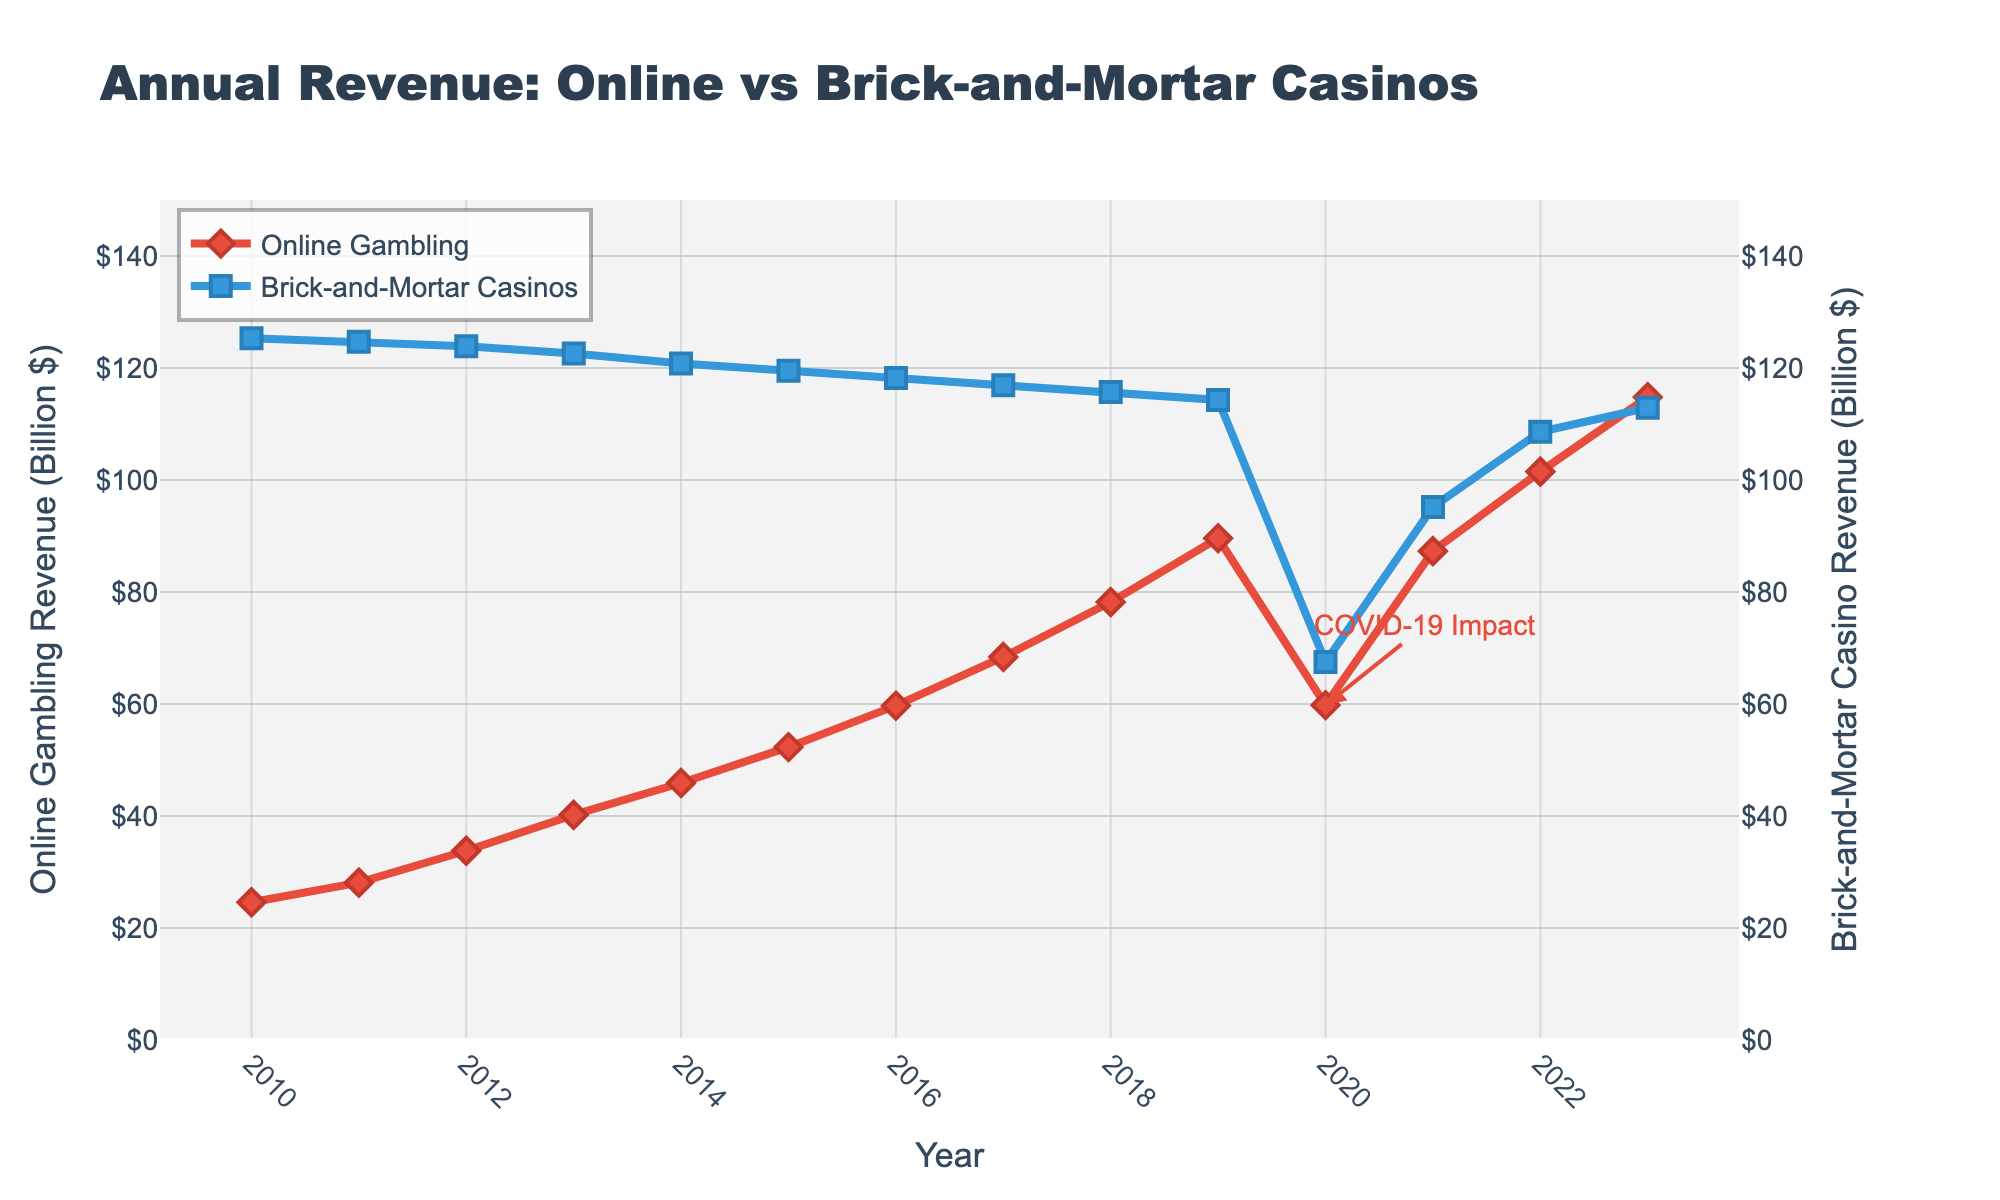What's the annual revenue of online gambling platforms in 2015? According to the figure, the data marker for 2015 representing the annual revenue of online gambling platforms is at 52.3 billion dollars.
Answer: 52.3 billion dollars How did the revenue of brick-and-mortar casinos change from 2010 to 2023? The revenue of brick-and-mortar casinos started at 125.3 billion dollars in 2010 and descended to 112.9 billion dollars in 2023. This indicates a gradual decline over the years.
Answer: Decreased from 125.3 to 112.9 billion dollars Which type of casino experienced a greater impact during the year 2020, and why? By observing the sharp decline in the graph for both online gambling platforms and brick-and-mortar casinos, brick-and-mortar casinos show a more significant drop from 114.3 billion to 67.5 billion dollars, whereas online gambling shows a drop but not as dramatic.
Answer: Brick-and-mortar casinos Which year shows the intersecting annual revenues close to each other between online platforms and brick-and-mortar casinos after the significant drop in 2020? Post the year 2020, in 2021, the revenues for both types nearly converge; online gambling reaches 87.3 billion dollars while brick-and-mortar casinos recover to 95.2 billion dollars.
Answer: 2021 What is the difference in the annual revenue of online gambling platforms between 2013 and 2023? The revenue for online gambling platforms in 2013 was 40.2 billion dollars, increasing to 114.8 billion dollars in 2023. To find the difference: 114.8 - 40.2 = 74.6 billion dollars.
Answer: 74.6 billion dollars What visual element highlights the impact of COVID-19 in 2020? The annotation text "COVID-19 Impact" is placed near the sharp decline in 2020 for both types of casinos, highlighting the significant financial impact caused by the pandemic.
Answer: The annotation "COVID-19 Impact" In which year did online gambling platforms surpass 100 billion dollars in revenue? The figure shows that online gambling platforms surpassed 100 billion dollars in the year 2022, reaching 101.5 billion dollars.
Answer: 2022 By how much did the annual revenue of brick-and-mortar casinos recover from 2020 to 2023? Brick-and-mortar casino revenue rose from 67.5 billion dollars in 2020 to 112.9 billion dollars in 2023. The difference is 112.9 - 67.5 = 45.4 billion dollars.
Answer: 45.4 billion dollars Which year shows the highest annual revenue for online gambling platforms, and what is the value? The highest annual revenue for online gambling platforms occurs in 2023 with a revenue value of 114.8 billion dollars.
Answer: 2023 